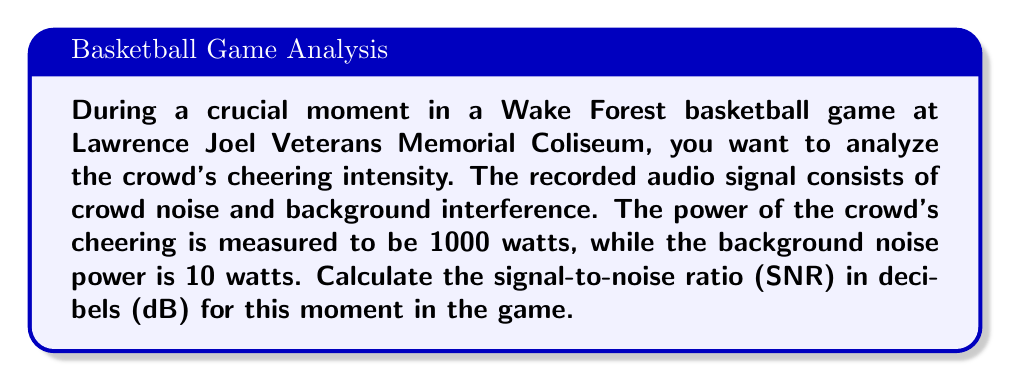Teach me how to tackle this problem. To solve this problem, we need to follow these steps:

1. Recall the formula for Signal-to-Noise Ratio (SNR) in decibels:

   $$ SNR_{dB} = 10 \log_{10}\left(\frac{P_{signal}}{P_{noise}}\right) $$

   Where $P_{signal}$ is the power of the signal (crowd cheering) and $P_{noise}$ is the power of the noise.

2. Identify the given values:
   $P_{signal} = 1000$ watts (crowd cheering power)
   $P_{noise} = 10$ watts (background noise power)

3. Substitute these values into the SNR formula:

   $$ SNR_{dB} = 10 \log_{10}\left(\frac{1000}{10}\right) $$

4. Simplify the fraction inside the logarithm:

   $$ SNR_{dB} = 10 \log_{10}(100) $$

5. Calculate the logarithm:
   $\log_{10}(100) = 2$

6. Multiply the result by 10:

   $$ SNR_{dB} = 10 \cdot 2 = 20 $$

Therefore, the signal-to-noise ratio of the crowd's cheering during this crucial moment in the Wake Forest game is 20 dB.
Answer: 20 dB 